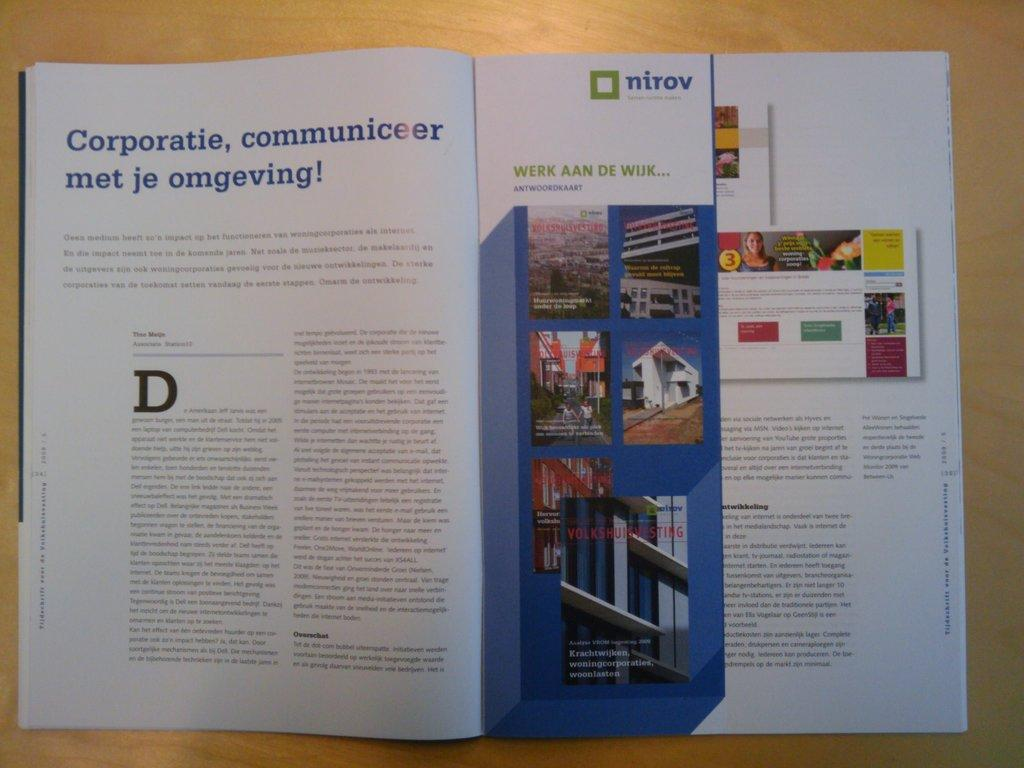<image>
Render a clear and concise summary of the photo. A book is open to a page that says Corporatie, communiceer met je omgeving. 